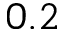<formula> <loc_0><loc_0><loc_500><loc_500>0 . 2</formula> 